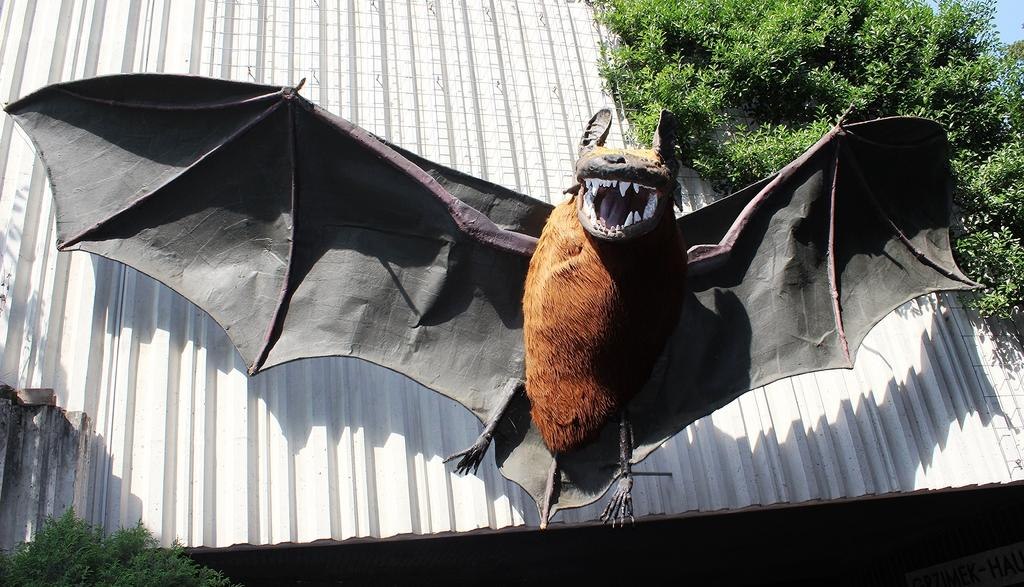What is the main subject of the picture? The main subject of the picture is a statue of a bat. What can be seen in the top right side of the picture? There are trees on the top right side of the picture. What type of fence is visible in the background of the picture? There is a metal rake fence in the background of the picture. Can you tell me how many goldfish are swimming in the statue of the bat? There are no goldfish present in the image, as it features a statue of a bat and trees, with a metal rake fence in the background. 